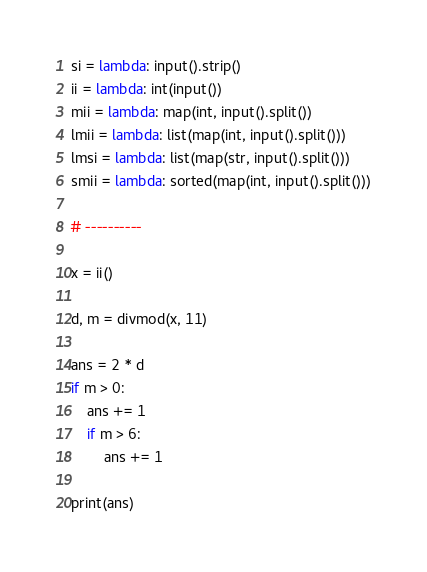<code> <loc_0><loc_0><loc_500><loc_500><_Python_>si = lambda: input().strip()
ii = lambda: int(input())
mii = lambda: map(int, input().split())
lmii = lambda: list(map(int, input().split()))
lmsi = lambda: list(map(str, input().split()))
smii = lambda: sorted(map(int, input().split()))

# ----------

x = ii()

d, m = divmod(x, 11)

ans = 2 * d
if m > 0:
    ans += 1
    if m > 6:
        ans += 1

print(ans)



</code> 